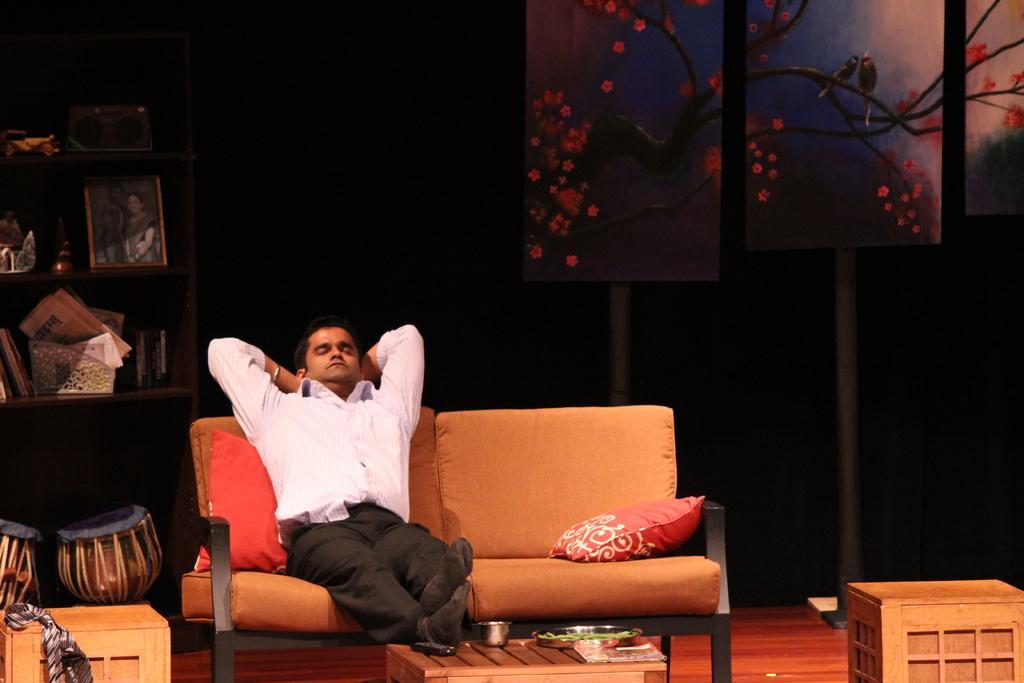How would you summarize this image in a sentence or two? in a room a person is sitting on a sofa in that room there are different items present in the room 